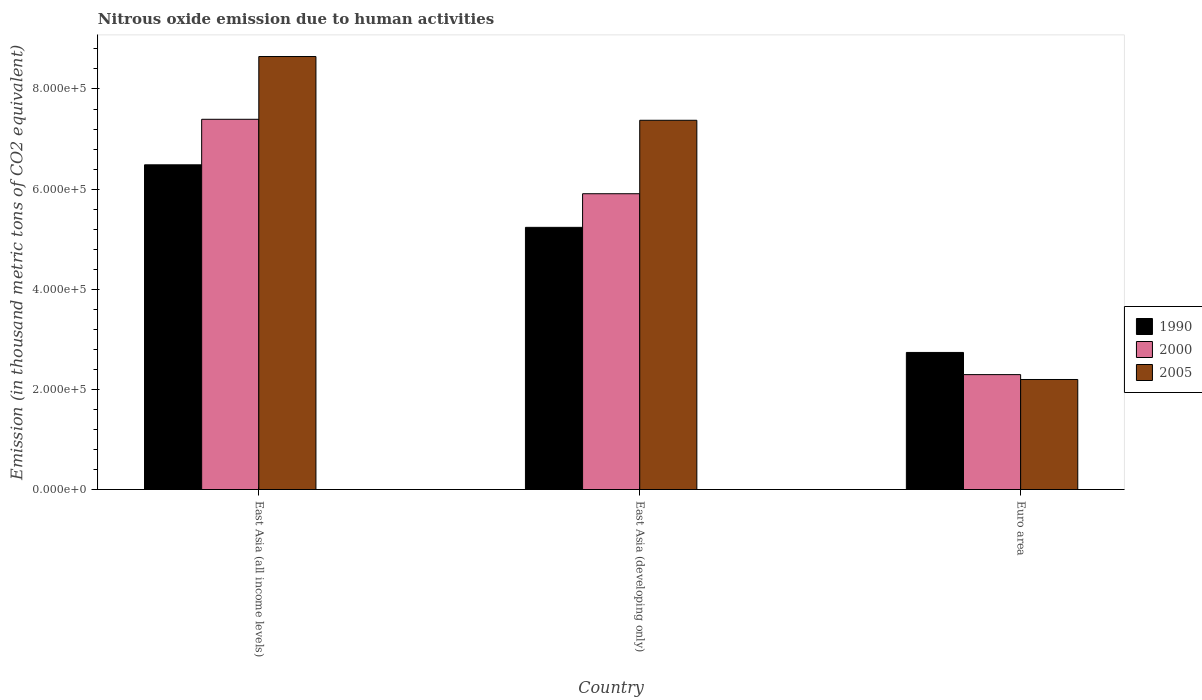Are the number of bars per tick equal to the number of legend labels?
Your answer should be very brief. Yes. How many bars are there on the 1st tick from the left?
Offer a very short reply. 3. How many bars are there on the 3rd tick from the right?
Provide a short and direct response. 3. What is the label of the 2nd group of bars from the left?
Keep it short and to the point. East Asia (developing only). In how many cases, is the number of bars for a given country not equal to the number of legend labels?
Offer a terse response. 0. What is the amount of nitrous oxide emitted in 1990 in East Asia (developing only)?
Give a very brief answer. 5.24e+05. Across all countries, what is the maximum amount of nitrous oxide emitted in 2005?
Provide a short and direct response. 8.65e+05. Across all countries, what is the minimum amount of nitrous oxide emitted in 1990?
Keep it short and to the point. 2.74e+05. In which country was the amount of nitrous oxide emitted in 2005 maximum?
Make the answer very short. East Asia (all income levels). In which country was the amount of nitrous oxide emitted in 1990 minimum?
Keep it short and to the point. Euro area. What is the total amount of nitrous oxide emitted in 1990 in the graph?
Ensure brevity in your answer.  1.45e+06. What is the difference between the amount of nitrous oxide emitted in 1990 in East Asia (developing only) and that in Euro area?
Your answer should be compact. 2.50e+05. What is the difference between the amount of nitrous oxide emitted in 2005 in East Asia (all income levels) and the amount of nitrous oxide emitted in 1990 in East Asia (developing only)?
Your response must be concise. 3.41e+05. What is the average amount of nitrous oxide emitted in 1990 per country?
Ensure brevity in your answer.  4.82e+05. What is the difference between the amount of nitrous oxide emitted of/in 2005 and amount of nitrous oxide emitted of/in 2000 in East Asia (developing only)?
Offer a terse response. 1.47e+05. What is the ratio of the amount of nitrous oxide emitted in 1990 in East Asia (developing only) to that in Euro area?
Keep it short and to the point. 1.91. Is the amount of nitrous oxide emitted in 2005 in East Asia (all income levels) less than that in East Asia (developing only)?
Give a very brief answer. No. What is the difference between the highest and the second highest amount of nitrous oxide emitted in 1990?
Your response must be concise. -1.25e+05. What is the difference between the highest and the lowest amount of nitrous oxide emitted in 2000?
Keep it short and to the point. 5.10e+05. In how many countries, is the amount of nitrous oxide emitted in 2000 greater than the average amount of nitrous oxide emitted in 2000 taken over all countries?
Keep it short and to the point. 2. What does the 1st bar from the left in East Asia (developing only) represents?
Offer a terse response. 1990. How many bars are there?
Give a very brief answer. 9. Are all the bars in the graph horizontal?
Your answer should be compact. No. How many countries are there in the graph?
Your answer should be very brief. 3. What is the difference between two consecutive major ticks on the Y-axis?
Your answer should be compact. 2.00e+05. Does the graph contain grids?
Offer a very short reply. No. How are the legend labels stacked?
Give a very brief answer. Vertical. What is the title of the graph?
Make the answer very short. Nitrous oxide emission due to human activities. Does "1985" appear as one of the legend labels in the graph?
Offer a terse response. No. What is the label or title of the Y-axis?
Make the answer very short. Emission (in thousand metric tons of CO2 equivalent). What is the Emission (in thousand metric tons of CO2 equivalent) in 1990 in East Asia (all income levels)?
Your response must be concise. 6.49e+05. What is the Emission (in thousand metric tons of CO2 equivalent) in 2000 in East Asia (all income levels)?
Your response must be concise. 7.39e+05. What is the Emission (in thousand metric tons of CO2 equivalent) in 2005 in East Asia (all income levels)?
Provide a succinct answer. 8.65e+05. What is the Emission (in thousand metric tons of CO2 equivalent) of 1990 in East Asia (developing only)?
Your answer should be very brief. 5.24e+05. What is the Emission (in thousand metric tons of CO2 equivalent) of 2000 in East Asia (developing only)?
Offer a terse response. 5.91e+05. What is the Emission (in thousand metric tons of CO2 equivalent) of 2005 in East Asia (developing only)?
Provide a succinct answer. 7.38e+05. What is the Emission (in thousand metric tons of CO2 equivalent) of 1990 in Euro area?
Offer a terse response. 2.74e+05. What is the Emission (in thousand metric tons of CO2 equivalent) in 2000 in Euro area?
Your answer should be compact. 2.30e+05. What is the Emission (in thousand metric tons of CO2 equivalent) of 2005 in Euro area?
Ensure brevity in your answer.  2.20e+05. Across all countries, what is the maximum Emission (in thousand metric tons of CO2 equivalent) in 1990?
Offer a very short reply. 6.49e+05. Across all countries, what is the maximum Emission (in thousand metric tons of CO2 equivalent) in 2000?
Your answer should be very brief. 7.39e+05. Across all countries, what is the maximum Emission (in thousand metric tons of CO2 equivalent) in 2005?
Keep it short and to the point. 8.65e+05. Across all countries, what is the minimum Emission (in thousand metric tons of CO2 equivalent) of 1990?
Provide a succinct answer. 2.74e+05. Across all countries, what is the minimum Emission (in thousand metric tons of CO2 equivalent) in 2000?
Provide a short and direct response. 2.30e+05. Across all countries, what is the minimum Emission (in thousand metric tons of CO2 equivalent) in 2005?
Make the answer very short. 2.20e+05. What is the total Emission (in thousand metric tons of CO2 equivalent) of 1990 in the graph?
Keep it short and to the point. 1.45e+06. What is the total Emission (in thousand metric tons of CO2 equivalent) in 2000 in the graph?
Offer a very short reply. 1.56e+06. What is the total Emission (in thousand metric tons of CO2 equivalent) of 2005 in the graph?
Ensure brevity in your answer.  1.82e+06. What is the difference between the Emission (in thousand metric tons of CO2 equivalent) in 1990 in East Asia (all income levels) and that in East Asia (developing only)?
Keep it short and to the point. 1.25e+05. What is the difference between the Emission (in thousand metric tons of CO2 equivalent) in 2000 in East Asia (all income levels) and that in East Asia (developing only)?
Offer a very short reply. 1.49e+05. What is the difference between the Emission (in thousand metric tons of CO2 equivalent) in 2005 in East Asia (all income levels) and that in East Asia (developing only)?
Make the answer very short. 1.27e+05. What is the difference between the Emission (in thousand metric tons of CO2 equivalent) in 1990 in East Asia (all income levels) and that in Euro area?
Make the answer very short. 3.75e+05. What is the difference between the Emission (in thousand metric tons of CO2 equivalent) in 2000 in East Asia (all income levels) and that in Euro area?
Offer a very short reply. 5.10e+05. What is the difference between the Emission (in thousand metric tons of CO2 equivalent) of 2005 in East Asia (all income levels) and that in Euro area?
Provide a succinct answer. 6.45e+05. What is the difference between the Emission (in thousand metric tons of CO2 equivalent) in 1990 in East Asia (developing only) and that in Euro area?
Your answer should be very brief. 2.50e+05. What is the difference between the Emission (in thousand metric tons of CO2 equivalent) of 2000 in East Asia (developing only) and that in Euro area?
Offer a very short reply. 3.61e+05. What is the difference between the Emission (in thousand metric tons of CO2 equivalent) in 2005 in East Asia (developing only) and that in Euro area?
Provide a succinct answer. 5.18e+05. What is the difference between the Emission (in thousand metric tons of CO2 equivalent) of 1990 in East Asia (all income levels) and the Emission (in thousand metric tons of CO2 equivalent) of 2000 in East Asia (developing only)?
Your answer should be very brief. 5.78e+04. What is the difference between the Emission (in thousand metric tons of CO2 equivalent) in 1990 in East Asia (all income levels) and the Emission (in thousand metric tons of CO2 equivalent) in 2005 in East Asia (developing only)?
Provide a succinct answer. -8.90e+04. What is the difference between the Emission (in thousand metric tons of CO2 equivalent) of 2000 in East Asia (all income levels) and the Emission (in thousand metric tons of CO2 equivalent) of 2005 in East Asia (developing only)?
Provide a short and direct response. 1949.3. What is the difference between the Emission (in thousand metric tons of CO2 equivalent) in 1990 in East Asia (all income levels) and the Emission (in thousand metric tons of CO2 equivalent) in 2000 in Euro area?
Provide a succinct answer. 4.19e+05. What is the difference between the Emission (in thousand metric tons of CO2 equivalent) in 1990 in East Asia (all income levels) and the Emission (in thousand metric tons of CO2 equivalent) in 2005 in Euro area?
Provide a succinct answer. 4.29e+05. What is the difference between the Emission (in thousand metric tons of CO2 equivalent) in 2000 in East Asia (all income levels) and the Emission (in thousand metric tons of CO2 equivalent) in 2005 in Euro area?
Make the answer very short. 5.20e+05. What is the difference between the Emission (in thousand metric tons of CO2 equivalent) in 1990 in East Asia (developing only) and the Emission (in thousand metric tons of CO2 equivalent) in 2000 in Euro area?
Your answer should be very brief. 2.94e+05. What is the difference between the Emission (in thousand metric tons of CO2 equivalent) in 1990 in East Asia (developing only) and the Emission (in thousand metric tons of CO2 equivalent) in 2005 in Euro area?
Provide a short and direct response. 3.04e+05. What is the difference between the Emission (in thousand metric tons of CO2 equivalent) in 2000 in East Asia (developing only) and the Emission (in thousand metric tons of CO2 equivalent) in 2005 in Euro area?
Make the answer very short. 3.71e+05. What is the average Emission (in thousand metric tons of CO2 equivalent) of 1990 per country?
Offer a terse response. 4.82e+05. What is the average Emission (in thousand metric tons of CO2 equivalent) of 2000 per country?
Make the answer very short. 5.20e+05. What is the average Emission (in thousand metric tons of CO2 equivalent) in 2005 per country?
Your answer should be very brief. 6.07e+05. What is the difference between the Emission (in thousand metric tons of CO2 equivalent) in 1990 and Emission (in thousand metric tons of CO2 equivalent) in 2000 in East Asia (all income levels)?
Offer a very short reply. -9.09e+04. What is the difference between the Emission (in thousand metric tons of CO2 equivalent) of 1990 and Emission (in thousand metric tons of CO2 equivalent) of 2005 in East Asia (all income levels)?
Make the answer very short. -2.16e+05. What is the difference between the Emission (in thousand metric tons of CO2 equivalent) in 2000 and Emission (in thousand metric tons of CO2 equivalent) in 2005 in East Asia (all income levels)?
Provide a succinct answer. -1.25e+05. What is the difference between the Emission (in thousand metric tons of CO2 equivalent) in 1990 and Emission (in thousand metric tons of CO2 equivalent) in 2000 in East Asia (developing only)?
Your answer should be very brief. -6.71e+04. What is the difference between the Emission (in thousand metric tons of CO2 equivalent) in 1990 and Emission (in thousand metric tons of CO2 equivalent) in 2005 in East Asia (developing only)?
Your response must be concise. -2.14e+05. What is the difference between the Emission (in thousand metric tons of CO2 equivalent) in 2000 and Emission (in thousand metric tons of CO2 equivalent) in 2005 in East Asia (developing only)?
Your answer should be very brief. -1.47e+05. What is the difference between the Emission (in thousand metric tons of CO2 equivalent) of 1990 and Emission (in thousand metric tons of CO2 equivalent) of 2000 in Euro area?
Make the answer very short. 4.43e+04. What is the difference between the Emission (in thousand metric tons of CO2 equivalent) in 1990 and Emission (in thousand metric tons of CO2 equivalent) in 2005 in Euro area?
Your response must be concise. 5.40e+04. What is the difference between the Emission (in thousand metric tons of CO2 equivalent) in 2000 and Emission (in thousand metric tons of CO2 equivalent) in 2005 in Euro area?
Keep it short and to the point. 9758.6. What is the ratio of the Emission (in thousand metric tons of CO2 equivalent) in 1990 in East Asia (all income levels) to that in East Asia (developing only)?
Your answer should be compact. 1.24. What is the ratio of the Emission (in thousand metric tons of CO2 equivalent) of 2000 in East Asia (all income levels) to that in East Asia (developing only)?
Your answer should be compact. 1.25. What is the ratio of the Emission (in thousand metric tons of CO2 equivalent) of 2005 in East Asia (all income levels) to that in East Asia (developing only)?
Provide a succinct answer. 1.17. What is the ratio of the Emission (in thousand metric tons of CO2 equivalent) in 1990 in East Asia (all income levels) to that in Euro area?
Offer a very short reply. 2.37. What is the ratio of the Emission (in thousand metric tons of CO2 equivalent) of 2000 in East Asia (all income levels) to that in Euro area?
Keep it short and to the point. 3.22. What is the ratio of the Emission (in thousand metric tons of CO2 equivalent) in 2005 in East Asia (all income levels) to that in Euro area?
Your response must be concise. 3.94. What is the ratio of the Emission (in thousand metric tons of CO2 equivalent) of 1990 in East Asia (developing only) to that in Euro area?
Ensure brevity in your answer.  1.91. What is the ratio of the Emission (in thousand metric tons of CO2 equivalent) of 2000 in East Asia (developing only) to that in Euro area?
Offer a very short reply. 2.57. What is the ratio of the Emission (in thousand metric tons of CO2 equivalent) of 2005 in East Asia (developing only) to that in Euro area?
Ensure brevity in your answer.  3.36. What is the difference between the highest and the second highest Emission (in thousand metric tons of CO2 equivalent) of 1990?
Your response must be concise. 1.25e+05. What is the difference between the highest and the second highest Emission (in thousand metric tons of CO2 equivalent) of 2000?
Keep it short and to the point. 1.49e+05. What is the difference between the highest and the second highest Emission (in thousand metric tons of CO2 equivalent) of 2005?
Give a very brief answer. 1.27e+05. What is the difference between the highest and the lowest Emission (in thousand metric tons of CO2 equivalent) of 1990?
Provide a succinct answer. 3.75e+05. What is the difference between the highest and the lowest Emission (in thousand metric tons of CO2 equivalent) in 2000?
Offer a terse response. 5.10e+05. What is the difference between the highest and the lowest Emission (in thousand metric tons of CO2 equivalent) of 2005?
Provide a short and direct response. 6.45e+05. 